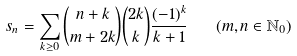Convert formula to latex. <formula><loc_0><loc_0><loc_500><loc_500>s _ { n } = \sum _ { k \geq 0 } { { \binom { n + k } { m + 2 k } } { \binom { 2 k } { k } } { \frac { ( - 1 ) ^ { k } } { k + 1 } } } \quad ( m , n \in \mathbb { N } _ { 0 } )</formula> 